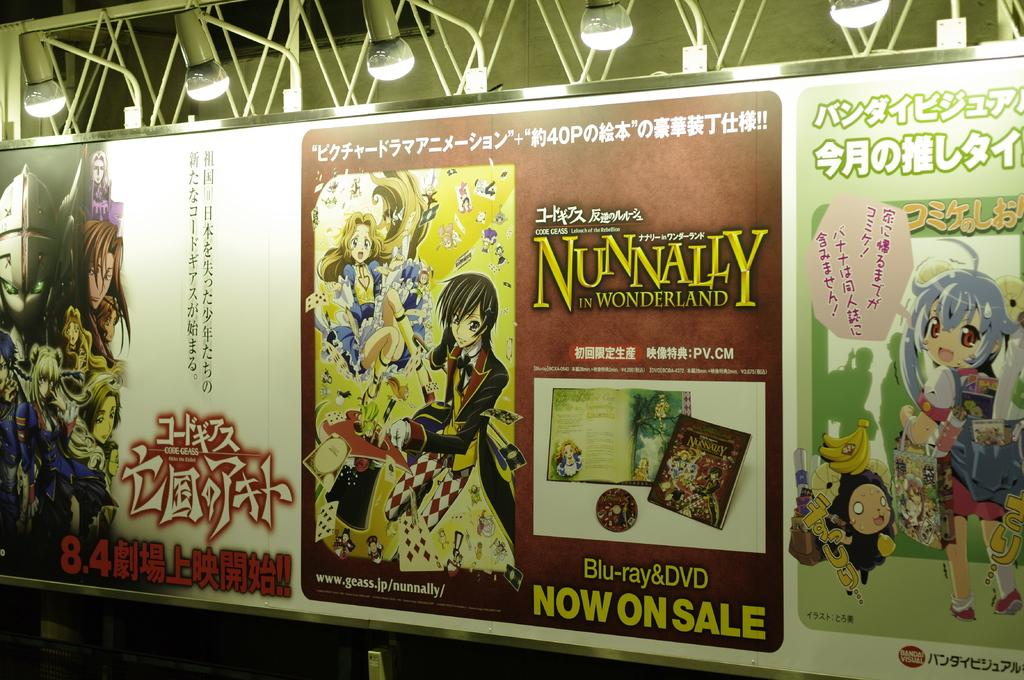Provide a one-sentence caption for the provided image. Posters for Japanese programs like Nunnally in Wonderland. 